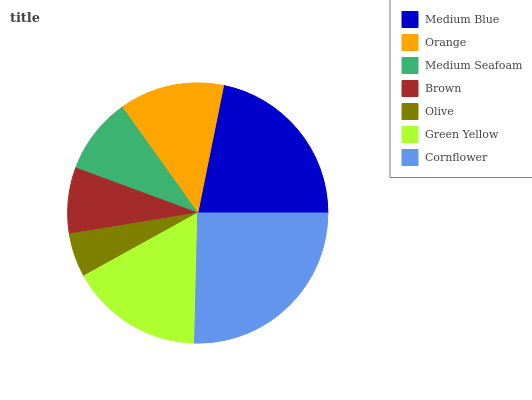Is Olive the minimum?
Answer yes or no. Yes. Is Cornflower the maximum?
Answer yes or no. Yes. Is Orange the minimum?
Answer yes or no. No. Is Orange the maximum?
Answer yes or no. No. Is Medium Blue greater than Orange?
Answer yes or no. Yes. Is Orange less than Medium Blue?
Answer yes or no. Yes. Is Orange greater than Medium Blue?
Answer yes or no. No. Is Medium Blue less than Orange?
Answer yes or no. No. Is Orange the high median?
Answer yes or no. Yes. Is Orange the low median?
Answer yes or no. Yes. Is Brown the high median?
Answer yes or no. No. Is Medium Seafoam the low median?
Answer yes or no. No. 